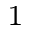Convert formula to latex. <formula><loc_0><loc_0><loc_500><loc_500>^ { 1 }</formula> 